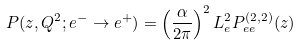Convert formula to latex. <formula><loc_0><loc_0><loc_500><loc_500>P ( z , Q ^ { 2 } ; e ^ { - } \rightarrow e ^ { + } ) = \left ( \frac { \alpha } { 2 \pi } \right ) ^ { 2 } L _ { e } ^ { 2 } P _ { e e } ^ { ( 2 , 2 ) } ( z )</formula> 